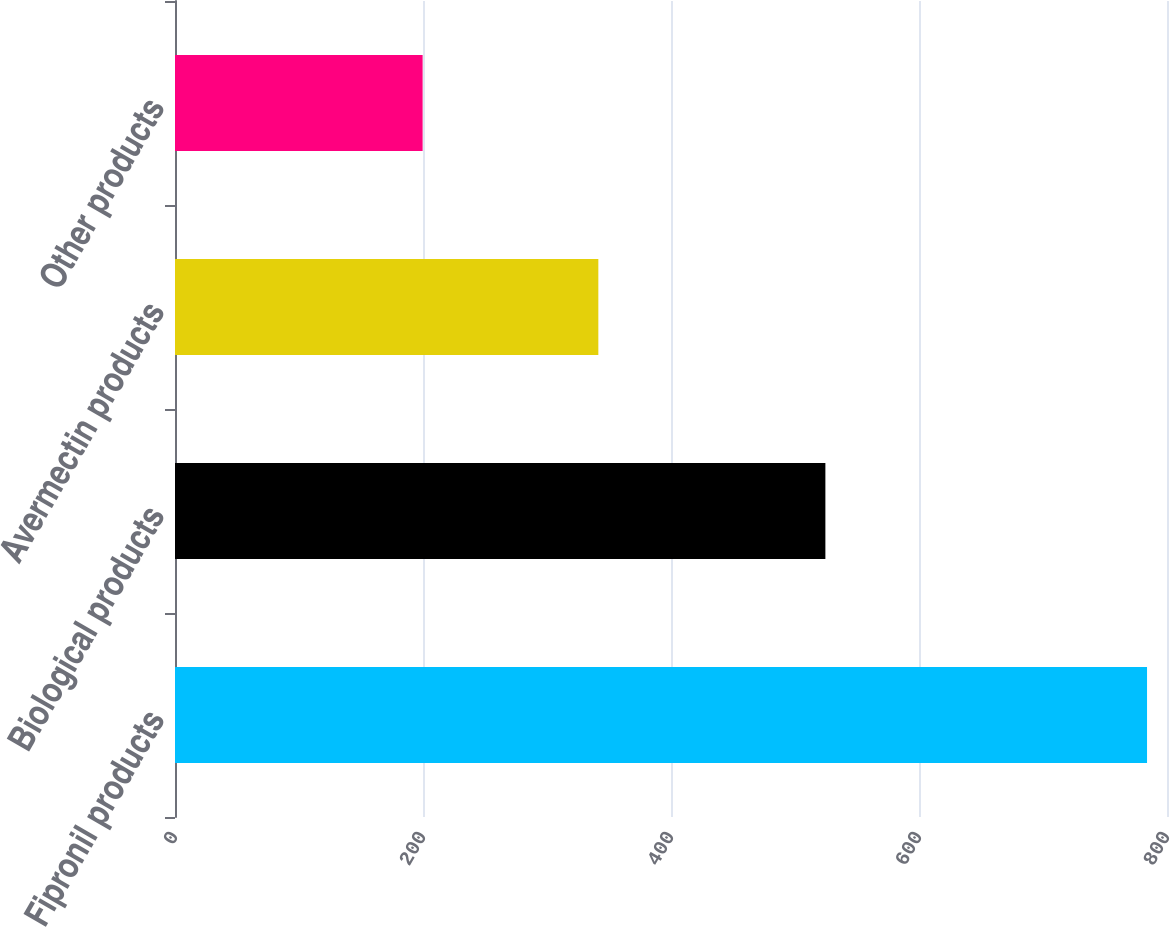Convert chart. <chart><loc_0><loc_0><loc_500><loc_500><bar_chart><fcel>Fipronil products<fcel>Biological products<fcel>Avermectin products<fcel>Other products<nl><fcel>783.9<fcel>524.5<fcel>341.4<fcel>199.7<nl></chart> 